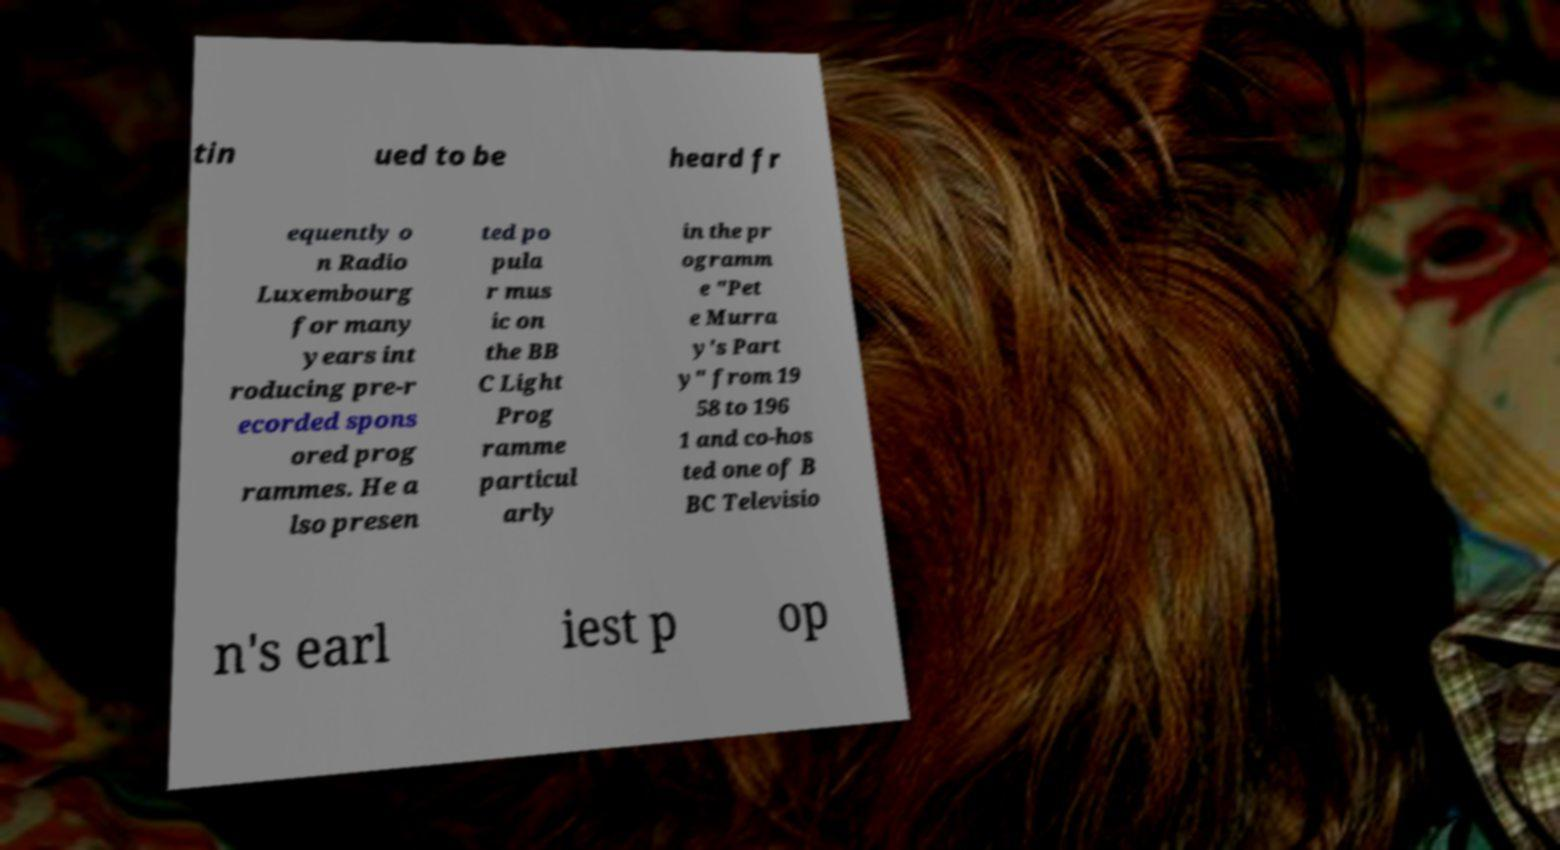Could you assist in decoding the text presented in this image and type it out clearly? tin ued to be heard fr equently o n Radio Luxembourg for many years int roducing pre-r ecorded spons ored prog rammes. He a lso presen ted po pula r mus ic on the BB C Light Prog ramme particul arly in the pr ogramm e "Pet e Murra y's Part y" from 19 58 to 196 1 and co-hos ted one of B BC Televisio n's earl iest p op 